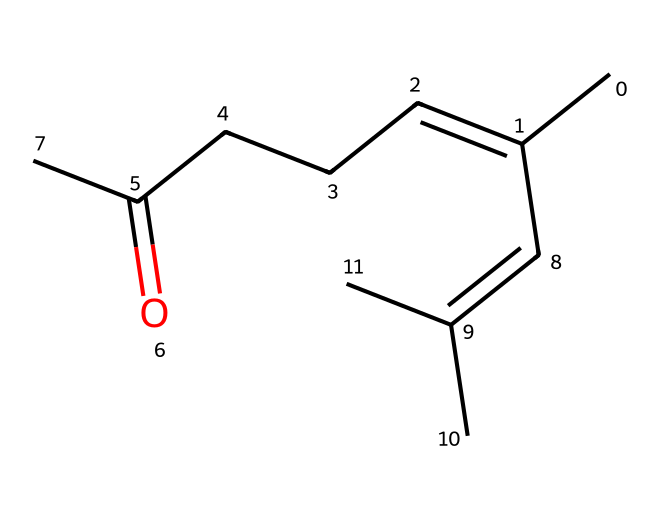How many carbon atoms are in citral? In the SMILES representation, "CC(=CCCC(=O)C)C=C(C)C" indicates several carbon atoms are connected. Counting each "C" shows there are 10 carbon atoms in total.
Answer: 10 What functional group is present in citral? The "C(=O)" part of the SMILES indicates the presence of a carbonyl group, which is characteristic of aldehydes. This functional group classifies it as an aldehyde.
Answer: aldehyde How many double bonds are present in citral? The "C=C" notation indicates there are two carbons connected by a double bond. Upon examining the structure, there is one double bond (C=C) and it appears only once.
Answer: 1 What is the main feature of citral that contributes to its aroma? The aldehyde functional group (C(=O)H) contributes to its characteristic scent, as aldehydes often have distinct aromatic properties and are found in many natural fragrances.
Answer: aldehyde Which part of the chemical structure indicates its unsaturation? The "C=C" segment of the SMILES illustrates the presence of a double bond, indicating unsaturation in the molecule. Unsaturation occurs when there are double or triple bonds between carbon atoms.
Answer: C=C Is citral a saturated or unsaturated aldehyde? The presence of a double bond (C=C) in the structure indicates that citral is unsaturated, as saturated aldehydes do not contain any double bonds.
Answer: unsaturated 